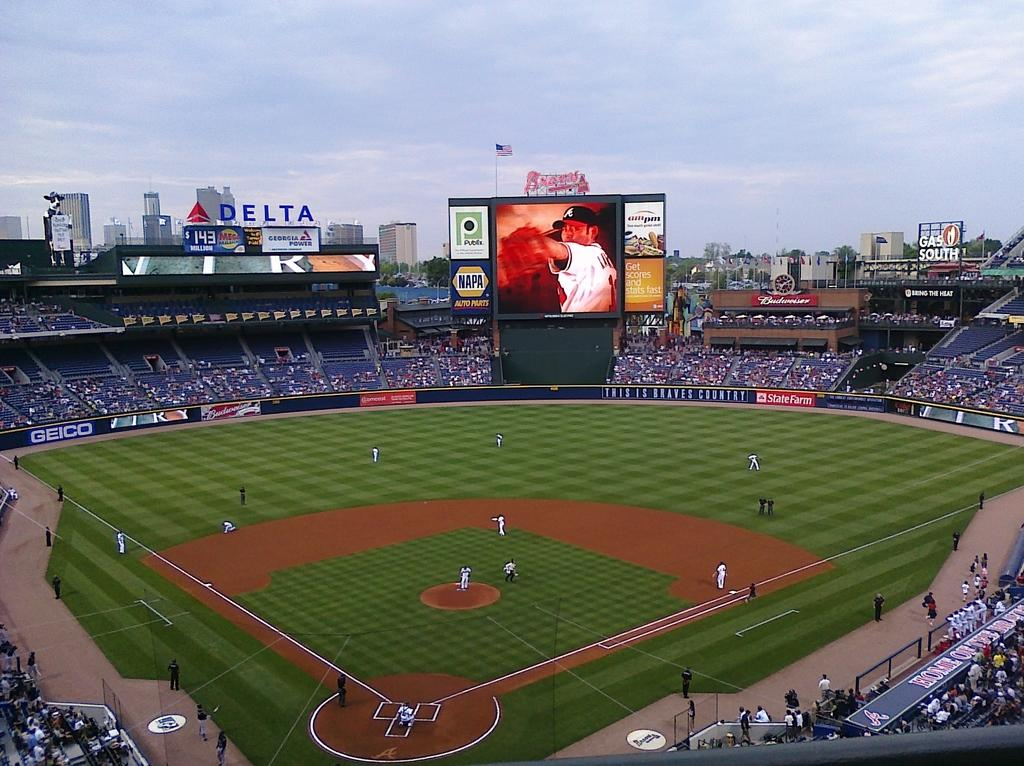<image>
Give a short and clear explanation of the subsequent image. A Delta ad sits above a Braves baseball game. 